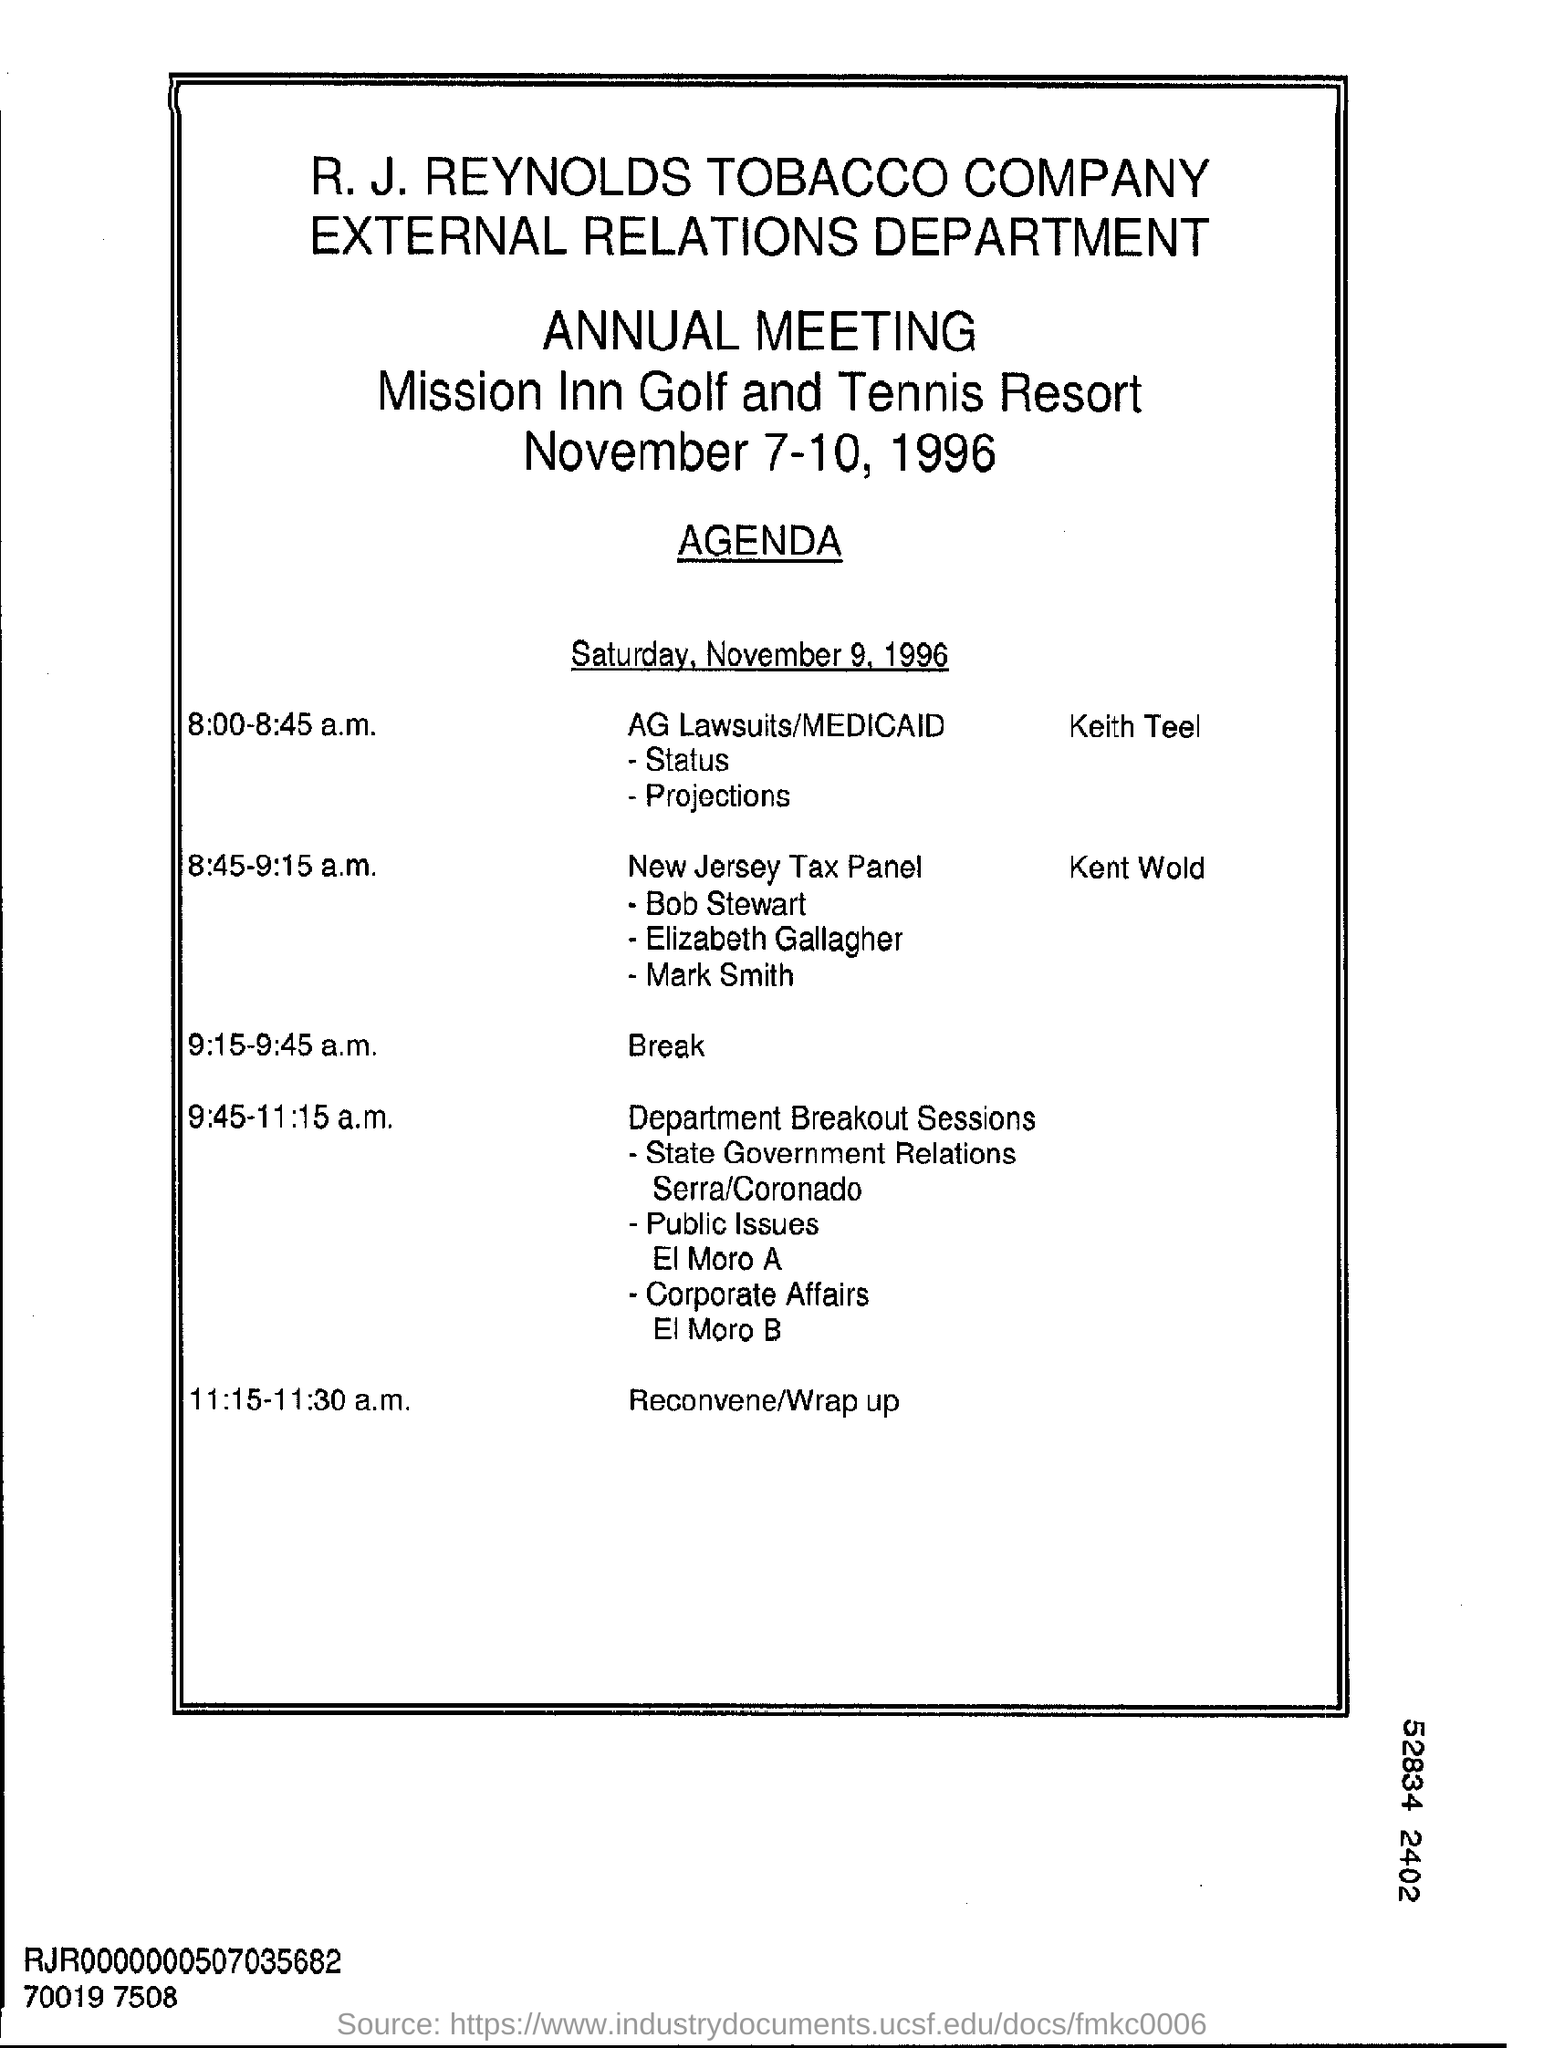What is the name of the tobacco company?
Make the answer very short. R.J. Reynolds tobacco company. What is the time scheduled for "break" ?
Ensure brevity in your answer.  9:15-9:45 a.m. 